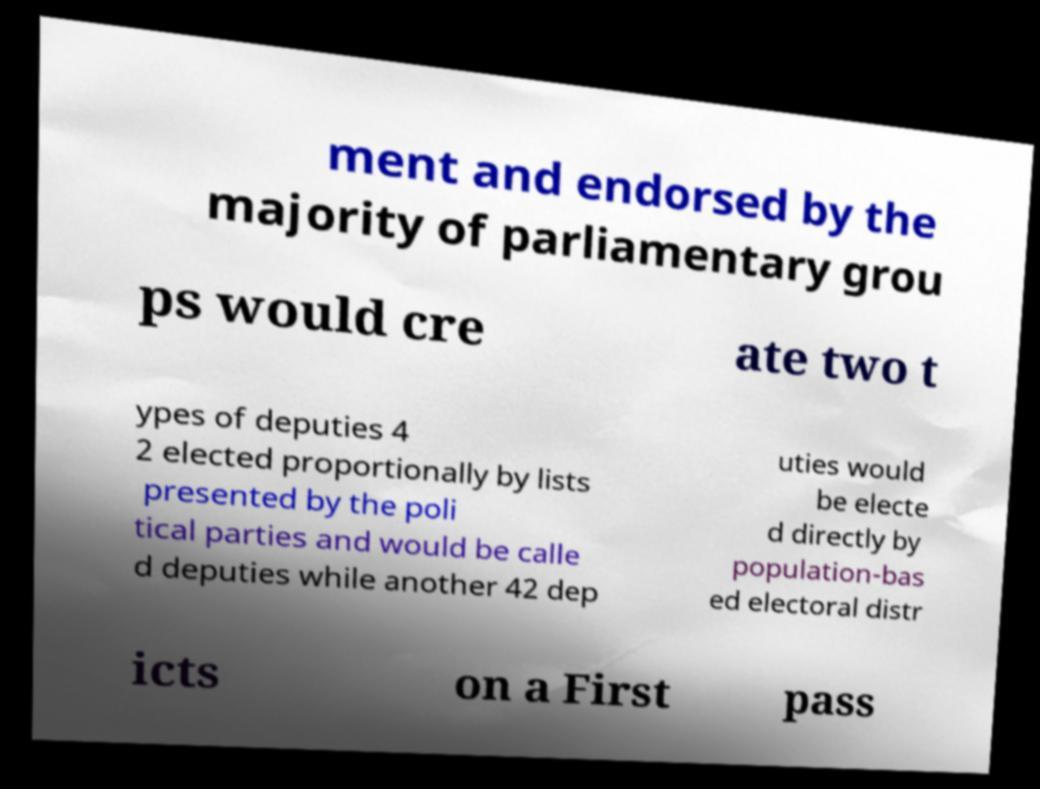I need the written content from this picture converted into text. Can you do that? ment and endorsed by the majority of parliamentary grou ps would cre ate two t ypes of deputies 4 2 elected proportionally by lists presented by the poli tical parties and would be calle d deputies while another 42 dep uties would be electe d directly by population-bas ed electoral distr icts on a First pass 